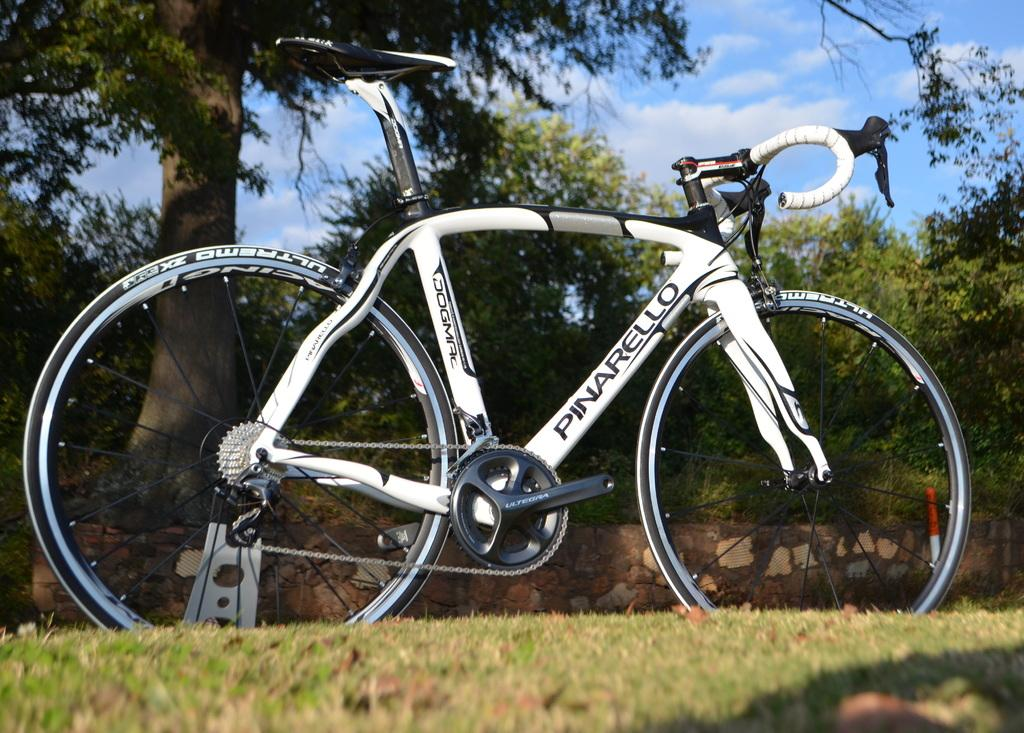What type of bicycle is in the picture? There is a white color bicycle in the picture. What can be seen in the background of the picture? There are trees, grass, and the sky visible in the background of the picture. What type of oatmeal is being served on the bicycle in the picture? There is no oatmeal present in the image; it is a picture of a white color bicycle with a background of trees, grass, and the sky. 